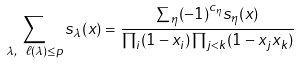<formula> <loc_0><loc_0><loc_500><loc_500>\sum _ { \lambda , \ \ell ( \lambda ) \leq p } s _ { \lambda } ( x ) = \frac { \sum _ { \eta } ( - 1 ) ^ { c _ { \eta } } s _ { \eta } ( x ) } { \prod _ { i } ( 1 - x _ { i } ) \prod _ { j < k } ( 1 - x _ { j } x _ { k } ) }</formula> 